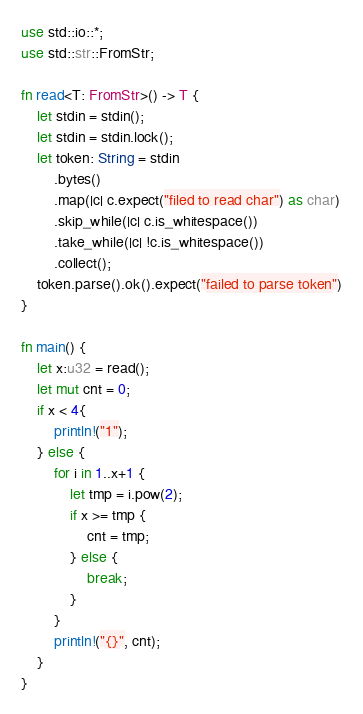<code> <loc_0><loc_0><loc_500><loc_500><_Rust_>use std::io::*;
use std::str::FromStr;

fn read<T: FromStr>() -> T {
    let stdin = stdin();
    let stdin = stdin.lock();
    let token: String = stdin
        .bytes()
        .map(|c| c.expect("filed to read char") as char)
        .skip_while(|c| c.is_whitespace())
        .take_while(|c| !c.is_whitespace())
        .collect();
    token.parse().ok().expect("failed to parse token")
}

fn main() {
    let x:u32 = read();
    let mut cnt = 0;
    if x < 4{
        println!("1");
    } else {
        for i in 1..x+1 {
            let tmp = i.pow(2);
            if x >= tmp {
                cnt = tmp;
            } else {
                break;
            }
        }
        println!("{}", cnt);
    }
}
</code> 